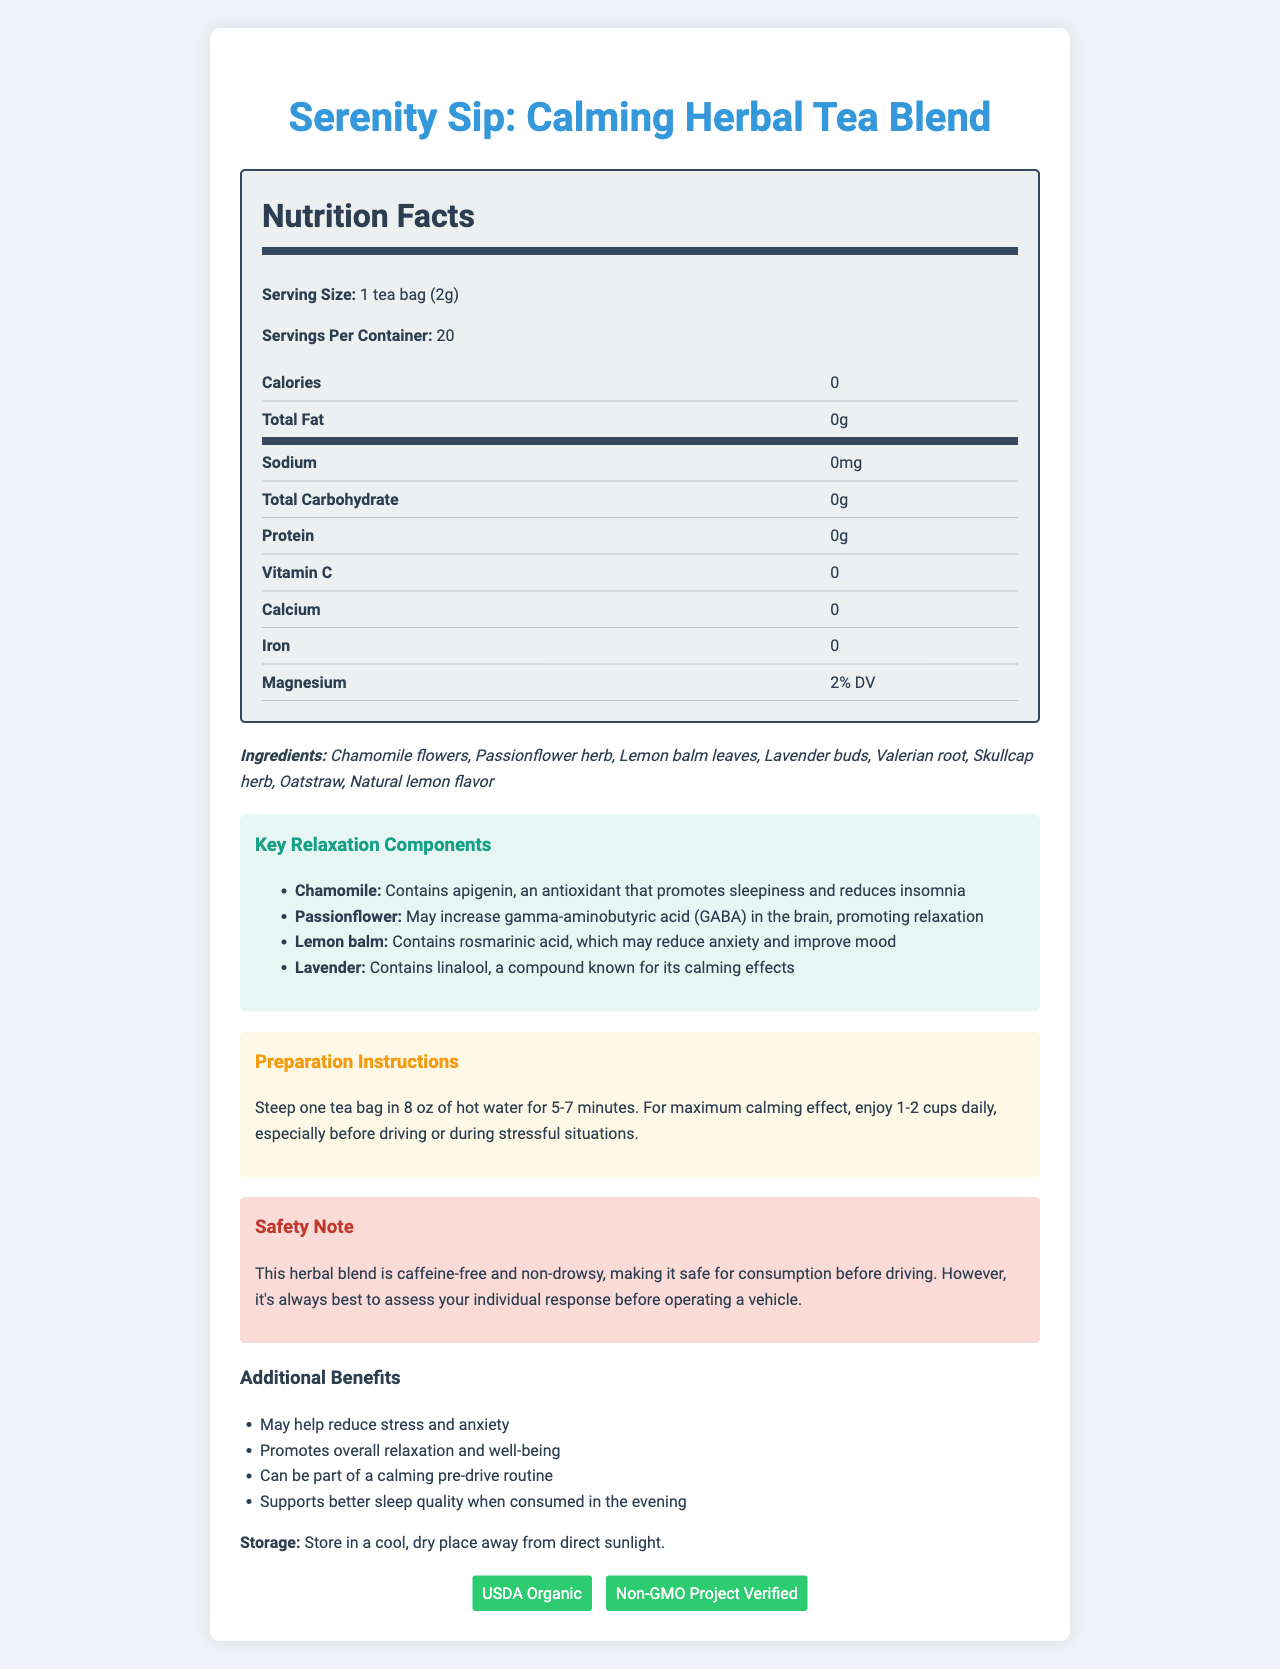what is the serving size of the Serenity Sip tea? The serving size is explicitly mentioned in the nutrition facts section of the document.
Answer: 1 tea bag (2g) how many servings are in one container of Serenity Sip tea? The document states that there are 20 servings per container.
Answer: 20 what are the key components in the Serenity Sip tea for promoting relaxation? The relaxation components are listed in the Key Relaxation Components section, along with their benefits.
Answer: Chamomile, Passionflower, Lemon balm, Lavender how much magnesium does each serving of Serenity Sip tea provide? The amount of magnesium per serving is specified in the nutrition facts table.
Answer: 2% DV what are the preparation instructions for Serenity Sip tea? The preparation instructions are clearly provided in the relevant section of the document.
Answer: Steep one tea bag in 8 oz of hot water for 5-7 minutes. For maximum calming effect, enjoy 1-2 cups daily, especially before driving or during stressful situations. is the Serenity Sip tea blend caffeine-free? The safety note explicitly states that the herbal blend is caffeine-free.
Answer: Yes what should you do if you want to store the Serenity Sip tea properly? The storage instructions are mentioned towards the end of the document.
Answer: Store in a cool, dry place away from direct sunlight. can the Serenity Sip tea be consumed safely before driving? The safety note indicates that the tea is non-drowsy and safe for consumption before driving, but it's suggested to assess your individual response.
Answer: Yes what are the certifications of the Serenity Sip tea? The certifications are listed in the document along with other details.
Answer: USDA Organic, Non-GMO Project Verified which component of Serenity Sip tea is known for containing apigenin that promotes sleepiness and reduces insomnia? A. Passionflower B. Lemon balm C. Lavender D. Chamomile The document states that Chamomile contains apigenin, which promotes sleepiness and reduces insomnia.
Answer: D which ingredient in Serenity Sip tea may help to reduce anxiety and improve mood due to rosmarinic acid? A. Chamomile B. Passionflower C. Lemon balm D. Skullcap herb The document specifies that Lemon balm contains rosmarinic acid, which may reduce anxiety and improve mood.
Answer: C does Serenity Sip tea contain any protein? The nutrition facts table states that the tea has 0g of protein.
Answer: No give a brief summary of the Serenity Sip tea document. The document emphasizes the relaxing properties of the tea, highlighting the specific benefits of its herbal components, preparation details, and safety information.
Answer: The Serenity Sip: Calming Herbal Tea Blend document provides detailed nutritional information, ingredients, key relaxation components, preparation instructions, safety notes, additional benefits, storage guidelines, and certifications. The tea is designed to promote relaxation and calmness, is caffeine-free, and includes beneficial herbs like Chamomile, Passionflower, Lemon balm, and Lavender. what is the source of the natural lemon flavor in the Serenity Sip tea? The document lists "Natural lemon flavor" as an ingredient but does not specify its source.
Answer: Not enough information does Serenity Sip tea have any calories? The nutrition facts section clearly shows that the tea has 0 calories.
Answer: No 